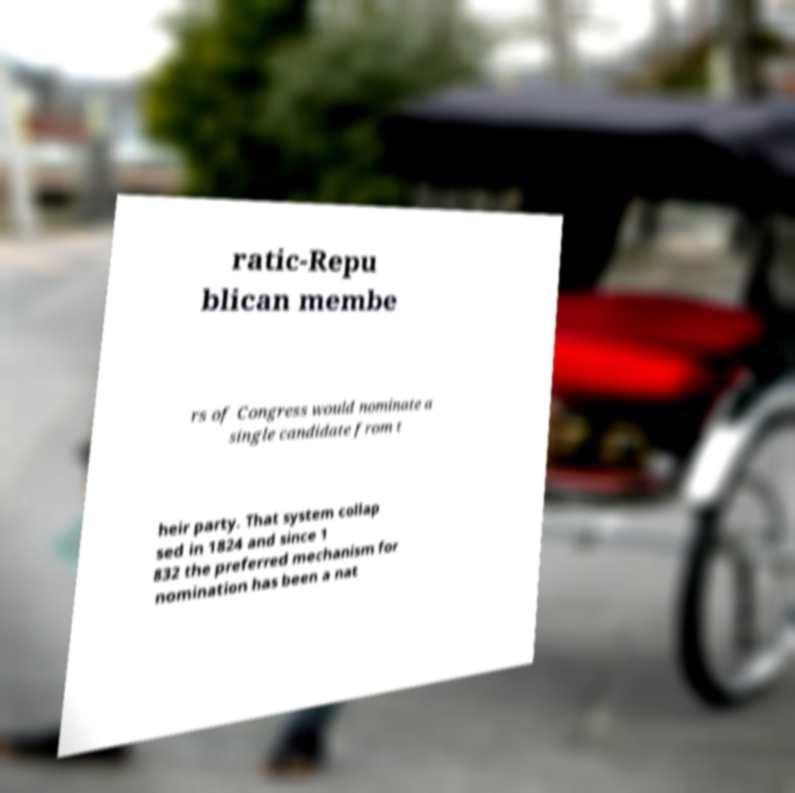Can you accurately transcribe the text from the provided image for me? ratic-Repu blican membe rs of Congress would nominate a single candidate from t heir party. That system collap sed in 1824 and since 1 832 the preferred mechanism for nomination has been a nat 